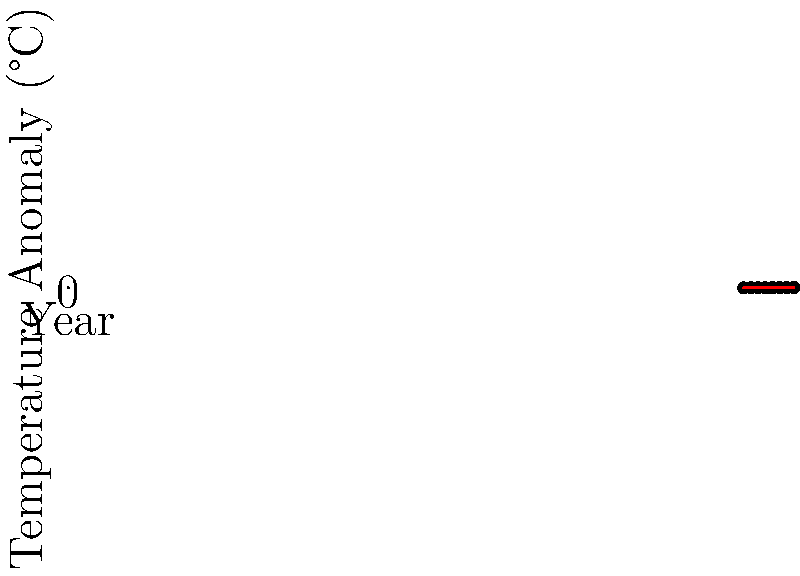As a film director raising awareness about climate change, you're creating a visual representation of global temperature changes. Using the provided 2D coordinate system, which shows temperature anomalies from 1880 to 2020, what is the approximate rate of temperature increase per decade based on the trend line? To calculate the rate of temperature increase per decade:

1. Identify the start and end points of the trend line:
   Start (1880, -0.2°C)
   End (2020, 1.0°C)

2. Calculate the total temperature change:
   $\Delta T = 1.0°C - (-0.2°C) = 1.2°C$

3. Calculate the time span:
   $\Delta t = 2020 - 1880 = 140$ years

4. Calculate the rate of change per year:
   Rate = $\frac{\Delta T}{\Delta t} = \frac{1.2°C}{140 \text{ years}} = 0.00857°C/\text{year}$

5. Convert to rate per decade:
   $0.00857°C/\text{year} \times 10 \text{ years/decade} = 0.0857°C/\text{decade}$

6. Round to two decimal places:
   $0.09°C/\text{decade}$
Answer: $0.09°C/\text{decade}$ 